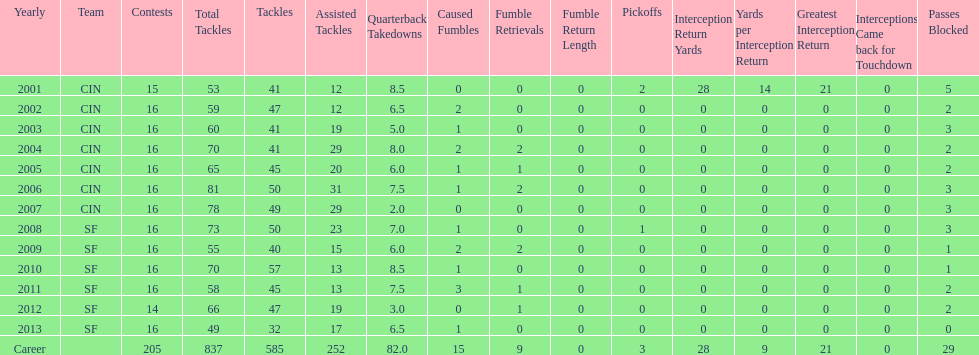How many consecutive years were there 20 or more assisted tackles? 5. 